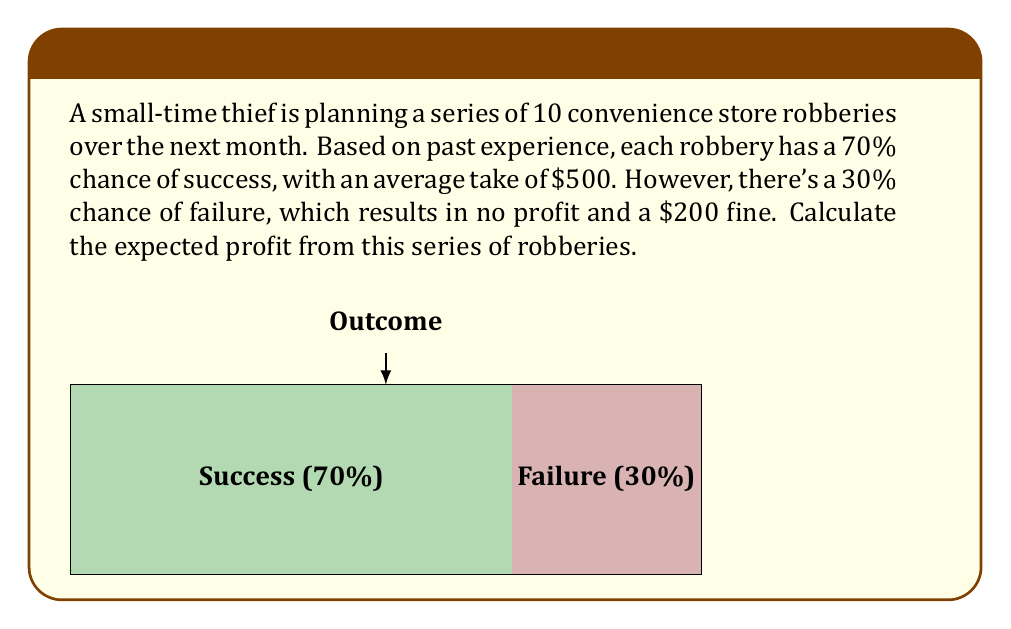What is the answer to this math problem? Let's break this down step-by-step:

1) First, let's calculate the expected value of a single robbery:

   Success: $0.70 \times \$500 = \$350$
   Failure: $0.30 \times (-\$200) = -\$60$

   Expected value: $\$350 + (-\$60) = \$290$

2) We can represent this mathematically as:

   $$E(\text{single robbery}) = 0.70 \times 500 + 0.30 \times (-200) = 290$$

3) Now, since there are 10 robberies planned, and each robbery is independent, we can multiply the expected value of a single robbery by 10:

   $$E(\text{10 robberies}) = 10 \times E(\text{single robbery})$$
   $$E(\text{10 robberies}) = 10 \times 290 = 2900$$

4) Therefore, the expected profit from the series of 10 robberies is $2900.

Note: This calculation assumes independence between robberies and constant probabilities, which may not be realistic in practice. Factors such as increased police attention or improved skills over time could alter these probabilities.
Answer: $2900 